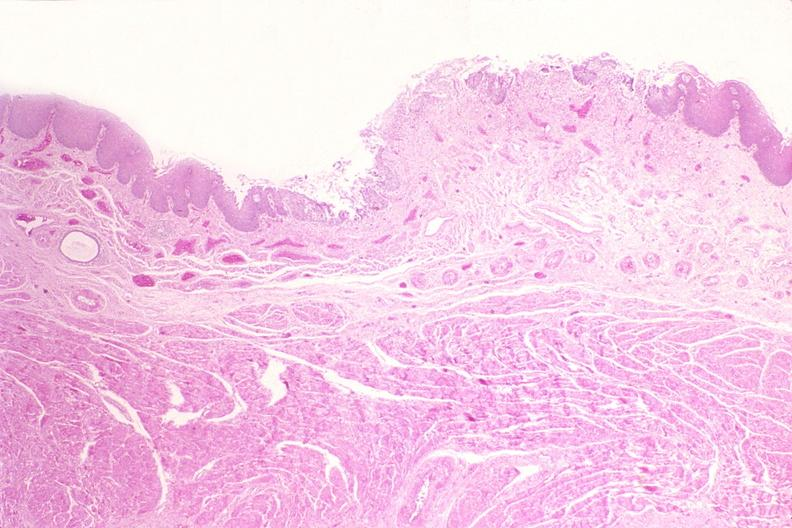where is this from?
Answer the question using a single word or phrase. Gastrointestinal system 